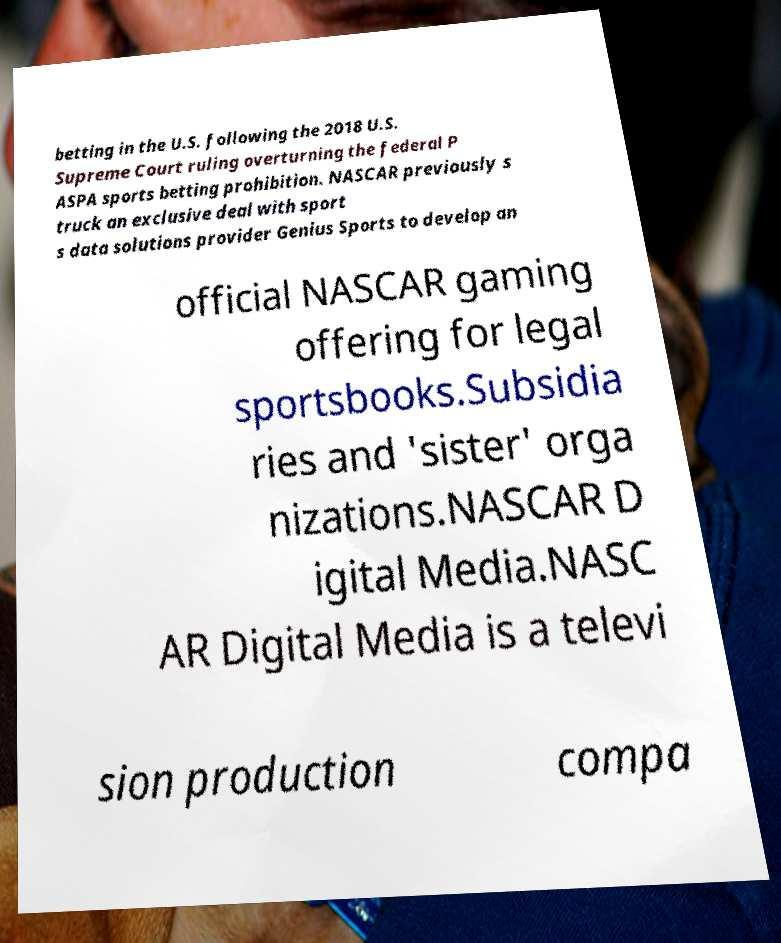Can you accurately transcribe the text from the provided image for me? betting in the U.S. following the 2018 U.S. Supreme Court ruling overturning the federal P ASPA sports betting prohibition. NASCAR previously s truck an exclusive deal with sport s data solutions provider Genius Sports to develop an official NASCAR gaming offering for legal sportsbooks.Subsidia ries and 'sister' orga nizations.NASCAR D igital Media.NASC AR Digital Media is a televi sion production compa 